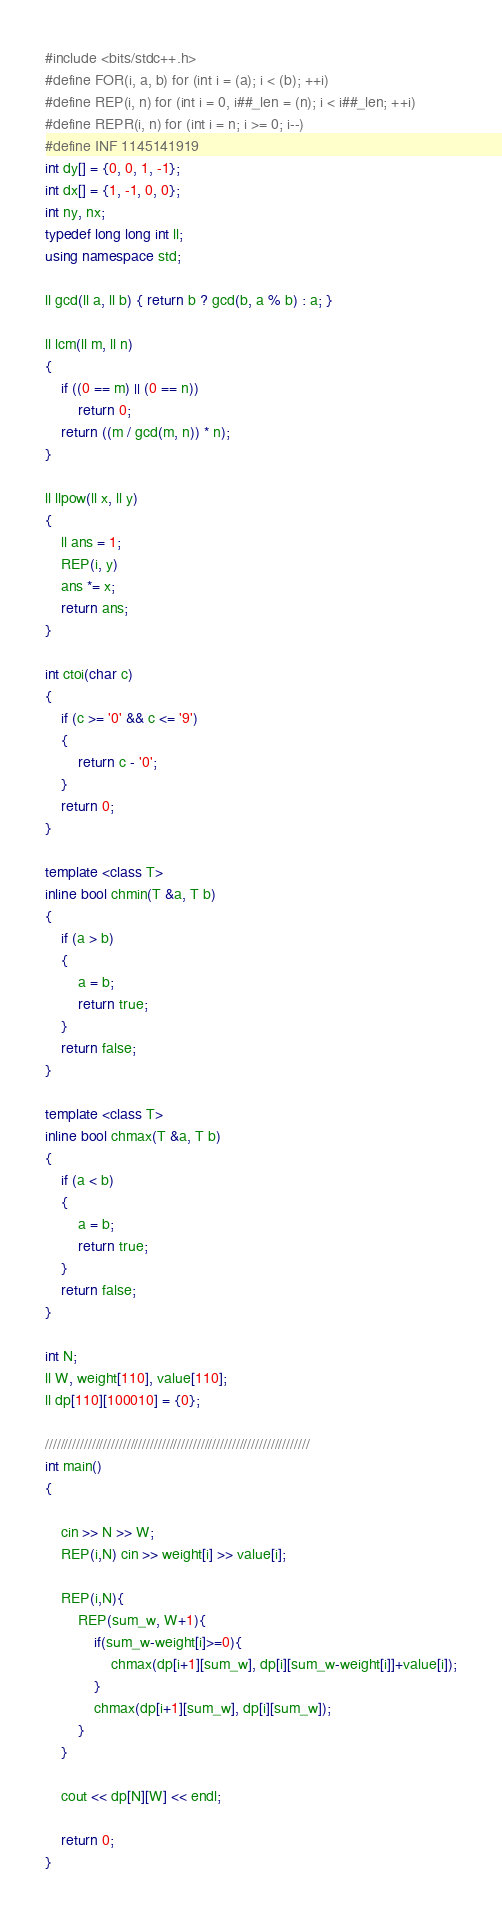Convert code to text. <code><loc_0><loc_0><loc_500><loc_500><_C++_>#include <bits/stdc++.h>
#define FOR(i, a, b) for (int i = (a); i < (b); ++i)
#define REP(i, n) for (int i = 0, i##_len = (n); i < i##_len; ++i)
#define REPR(i, n) for (int i = n; i >= 0; i--)
#define INF 1145141919
int dy[] = {0, 0, 1, -1};
int dx[] = {1, -1, 0, 0};
int ny, nx;
typedef long long int ll;
using namespace std;

ll gcd(ll a, ll b) { return b ? gcd(b, a % b) : a; }

ll lcm(ll m, ll n)
{
    if ((0 == m) || (0 == n))
        return 0;
    return ((m / gcd(m, n)) * n);
}

ll llpow(ll x, ll y)
{
    ll ans = 1;
    REP(i, y)
    ans *= x;
    return ans;
}

int ctoi(char c)
{
    if (c >= '0' && c <= '9')
    {
        return c - '0';
    }
    return 0;
}

template <class T>
inline bool chmin(T &a, T b)
{
    if (a > b)
    {
        a = b;
        return true;
    }
    return false;
}

template <class T>
inline bool chmax(T &a, T b)
{
    if (a < b)
    {
        a = b;
        return true;
    }
    return false;
}

int N;
ll W, weight[110], value[110];
ll dp[110][100010] = {0};

////////////////////////////////////////////////////////////////////
int main()
{

    cin >> N >> W;
    REP(i,N) cin >> weight[i] >> value[i];

    REP(i,N){
        REP(sum_w, W+1){
            if(sum_w-weight[i]>=0){
                chmax(dp[i+1][sum_w], dp[i][sum_w-weight[i]]+value[i]);
            }
            chmax(dp[i+1][sum_w], dp[i][sum_w]);
        }
    }

    cout << dp[N][W] << endl;

    return 0;
}
</code> 